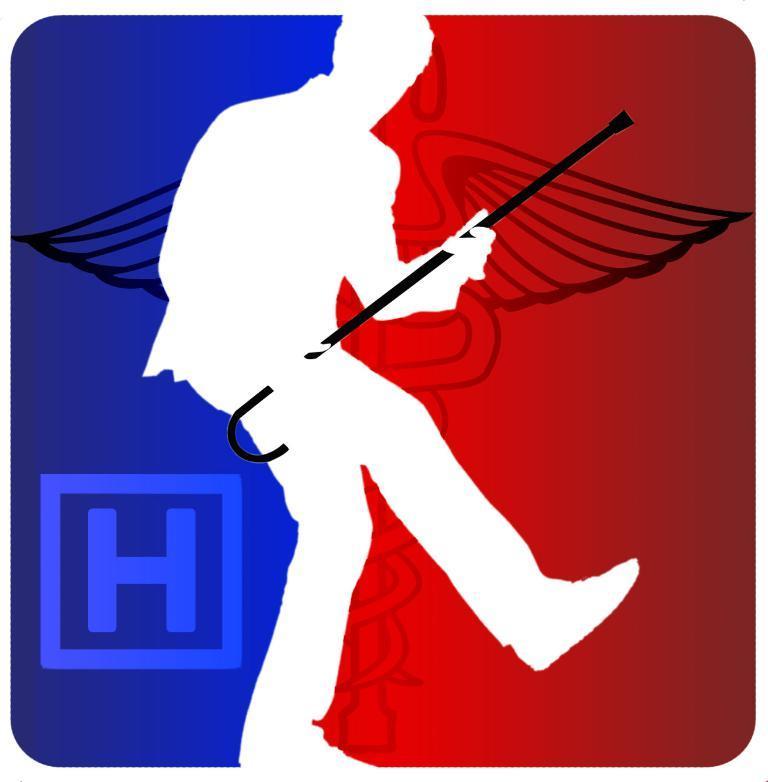Can you describe this image briefly? This is a painting. In this painting, we can see there is a person holding a stick. In the background, there is a letter and a design. And the background is in blue and red color combination. 